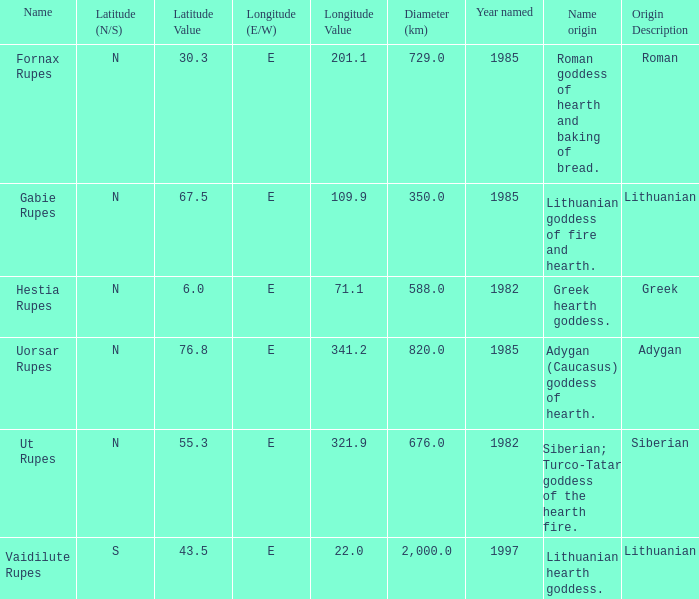What is the origin of the name for the feature located at 71.1 degrees latitude? Greek hearth goddess. 